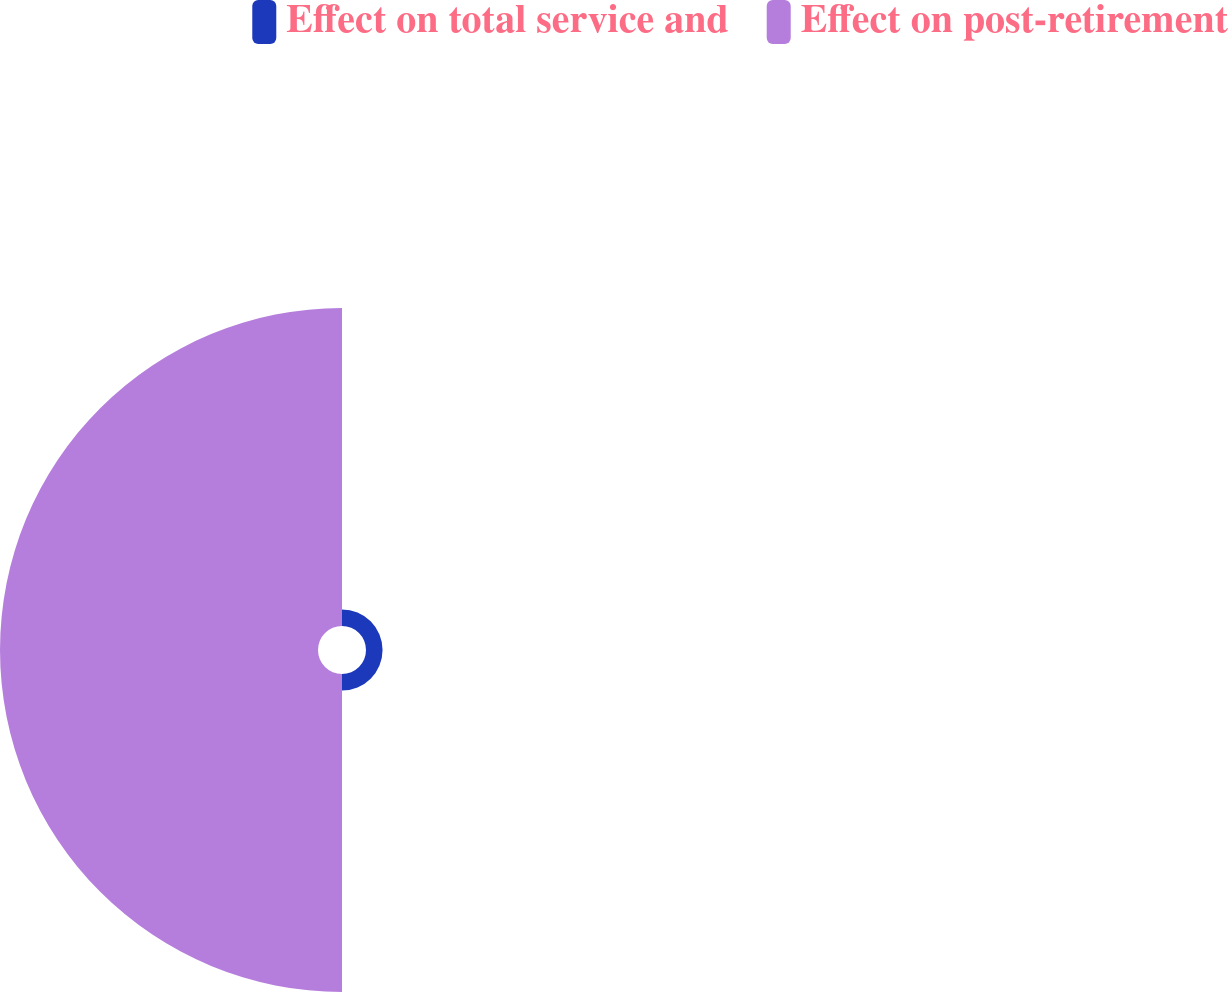Convert chart to OTSL. <chart><loc_0><loc_0><loc_500><loc_500><pie_chart><fcel>Effect on total service and<fcel>Effect on post-retirement<nl><fcel>4.95%<fcel>95.05%<nl></chart> 